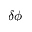Convert formula to latex. <formula><loc_0><loc_0><loc_500><loc_500>\delta \phi</formula> 